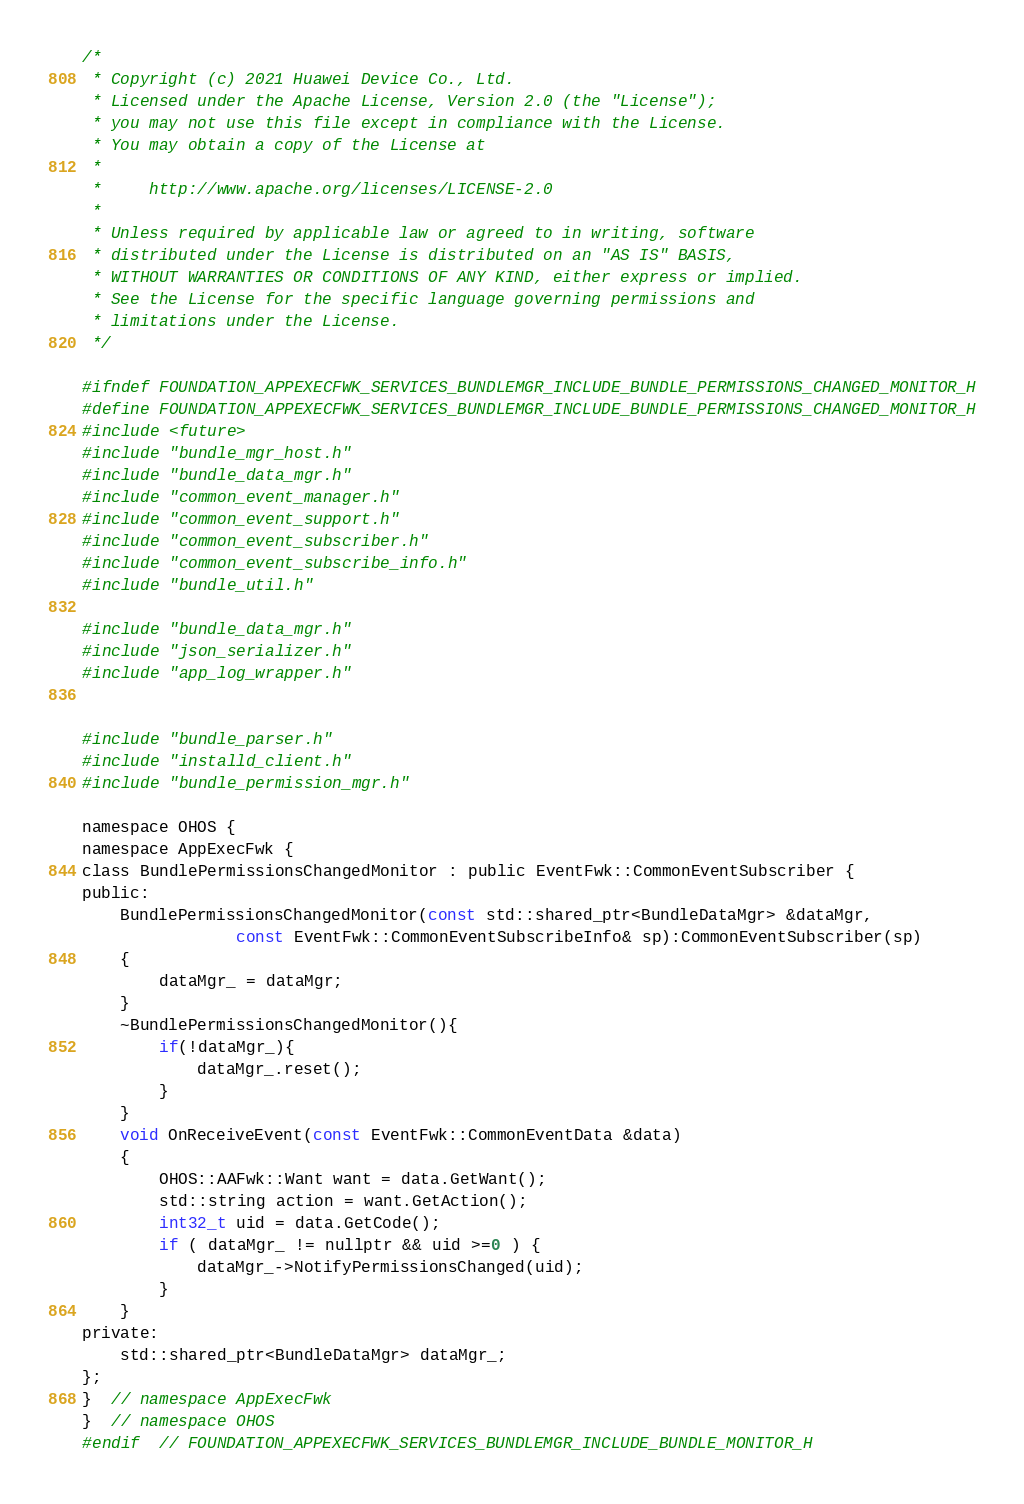<code> <loc_0><loc_0><loc_500><loc_500><_C_>/*
 * Copyright (c) 2021 Huawei Device Co., Ltd.
 * Licensed under the Apache License, Version 2.0 (the "License");
 * you may not use this file except in compliance with the License.
 * You may obtain a copy of the License at
 *
 *     http://www.apache.org/licenses/LICENSE-2.0
 *
 * Unless required by applicable law or agreed to in writing, software
 * distributed under the License is distributed on an "AS IS" BASIS,
 * WITHOUT WARRANTIES OR CONDITIONS OF ANY KIND, either express or implied.
 * See the License for the specific language governing permissions and
 * limitations under the License.
 */

#ifndef FOUNDATION_APPEXECFWK_SERVICES_BUNDLEMGR_INCLUDE_BUNDLE_PERMISSIONS_CHANGED_MONITOR_H
#define FOUNDATION_APPEXECFWK_SERVICES_BUNDLEMGR_INCLUDE_BUNDLE_PERMISSIONS_CHANGED_MONITOR_H
#include <future>
#include "bundle_mgr_host.h"
#include "bundle_data_mgr.h"
#include "common_event_manager.h"
#include "common_event_support.h"
#include "common_event_subscriber.h"
#include "common_event_subscribe_info.h"
#include "bundle_util.h"

#include "bundle_data_mgr.h"
#include "json_serializer.h"
#include "app_log_wrapper.h"


#include "bundle_parser.h"
#include "installd_client.h"
#include "bundle_permission_mgr.h"

namespace OHOS {
namespace AppExecFwk {
class BundlePermissionsChangedMonitor : public EventFwk::CommonEventSubscriber {
public:
    BundlePermissionsChangedMonitor(const std::shared_ptr<BundleDataMgr> &dataMgr,
                const EventFwk::CommonEventSubscribeInfo& sp):CommonEventSubscriber(sp)
    {
        dataMgr_ = dataMgr;
    }
    ~BundlePermissionsChangedMonitor(){
        if(!dataMgr_){
            dataMgr_.reset();
        }
    }
    void OnReceiveEvent(const EventFwk::CommonEventData &data)
    {
        OHOS::AAFwk::Want want = data.GetWant();
        std::string action = want.GetAction();
        int32_t uid = data.GetCode();
        if ( dataMgr_ != nullptr && uid >=0 ) {
            dataMgr_->NotifyPermissionsChanged(uid);
        }
    }
private:
    std::shared_ptr<BundleDataMgr> dataMgr_;
};
}  // namespace AppExecFwk
}  // namespace OHOS
#endif  // FOUNDATION_APPEXECFWK_SERVICES_BUNDLEMGR_INCLUDE_BUNDLE_MONITOR_H</code> 